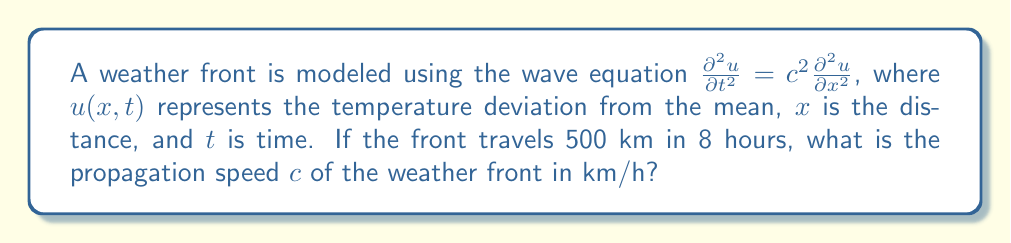Give your solution to this math problem. To solve this problem, we'll follow these steps:

1) The wave equation $\frac{\partial^2 u}{\partial t^2} = c^2 \frac{\partial^2 u}{\partial x^2}$ describes the propagation of waves, including weather fronts. Here, $c$ represents the propagation speed.

2) We're given that the front travels 500 km in 8 hours. We can use the basic speed equation:

   $$\text{Speed} = \frac{\text{Distance}}{\text{Time}}$$

3) Let's plug in our values:

   $$c = \frac{500 \text{ km}}{8 \text{ hours}}$$

4) Now, we simply need to perform the division:

   $$c = 62.5 \text{ km/h}$$

This result gives us the propagation speed of the weather front.
Answer: 62.5 km/h 